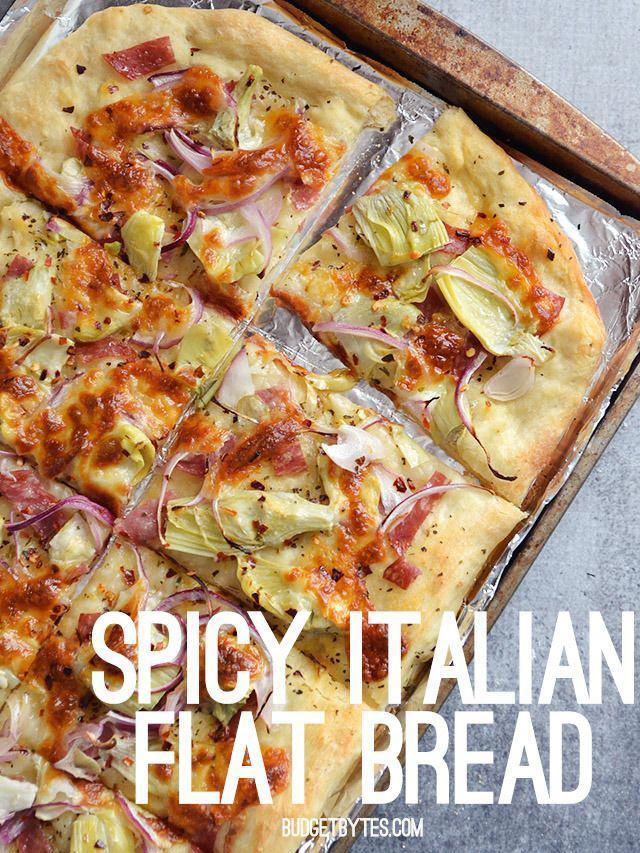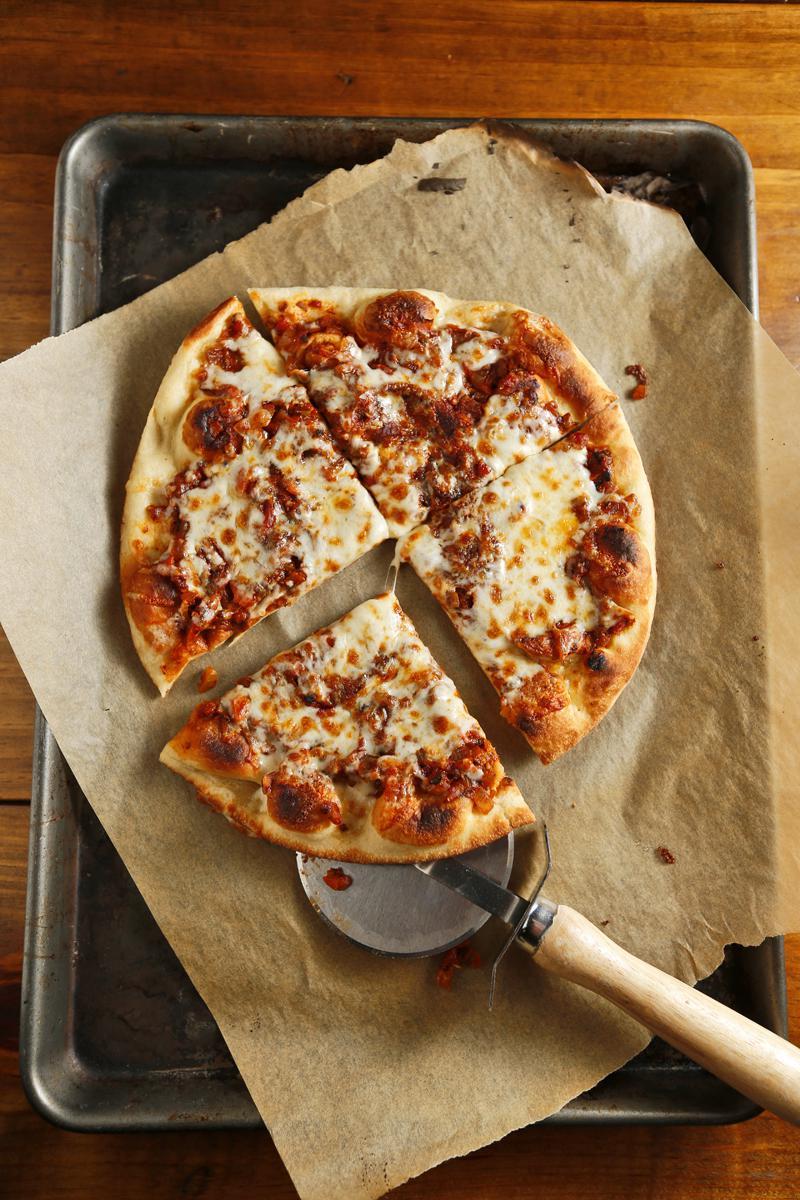The first image is the image on the left, the second image is the image on the right. Assess this claim about the two images: "There is a pizza cutter in the right image.". Correct or not? Answer yes or no. Yes. 